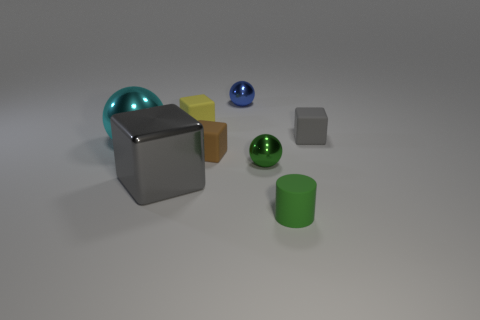Subtract all large metal spheres. How many spheres are left? 2 Subtract all red cylinders. How many gray cubes are left? 2 Add 1 tiny matte cylinders. How many objects exist? 9 Subtract all yellow blocks. How many blocks are left? 3 Add 1 small matte objects. How many small matte objects are left? 5 Add 8 gray rubber things. How many gray rubber things exist? 9 Subtract 2 gray blocks. How many objects are left? 6 Subtract all spheres. How many objects are left? 5 Subtract all red cubes. Subtract all brown balls. How many cubes are left? 4 Subtract all large things. Subtract all small matte cylinders. How many objects are left? 5 